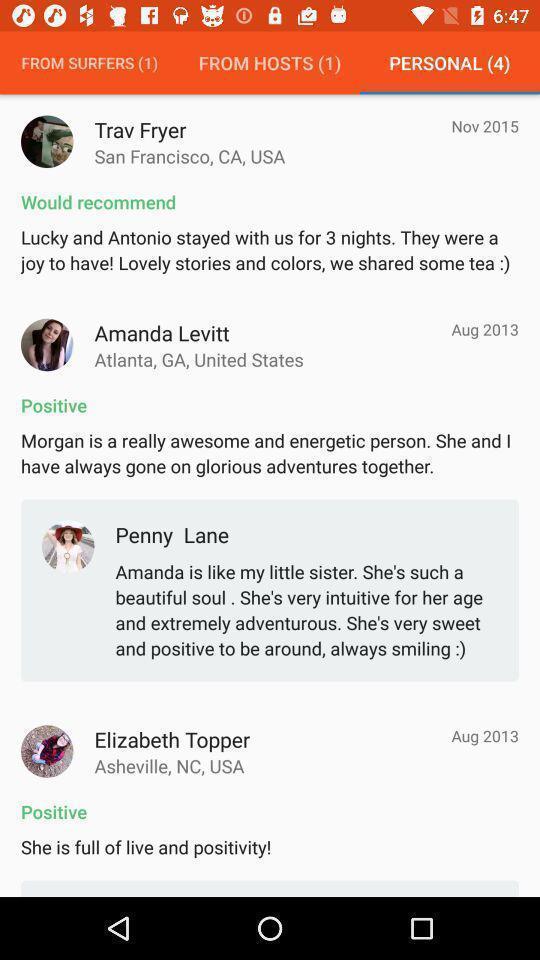Explain the elements present in this screenshot. Page showing positive comments. 